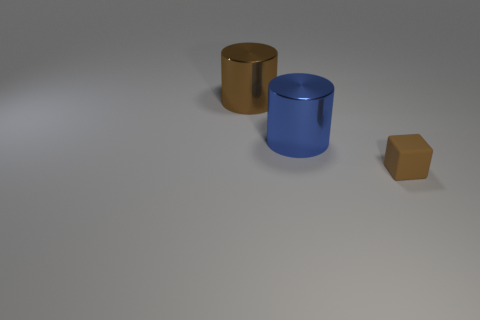The brown shiny thing that is the same shape as the blue metal thing is what size?
Give a very brief answer. Large. Is there any other thing that is the same size as the brown matte thing?
Provide a succinct answer. No. What number of other objects are there of the same color as the matte thing?
Give a very brief answer. 1. How many cylinders are either cyan shiny things or big blue objects?
Make the answer very short. 1. There is a big thing that is on the right side of the brown metallic cylinder that is to the left of the blue cylinder; what color is it?
Your answer should be very brief. Blue. The rubber thing has what shape?
Provide a short and direct response. Cube. Is the size of the metallic object that is right of the brown metal cylinder the same as the brown shiny thing?
Offer a terse response. Yes. Are there any other big cylinders that have the same material as the large blue cylinder?
Provide a succinct answer. Yes. What number of objects are either cylinders that are behind the blue metallic thing or tiny purple cylinders?
Ensure brevity in your answer.  1. Are any big blocks visible?
Your response must be concise. No. 